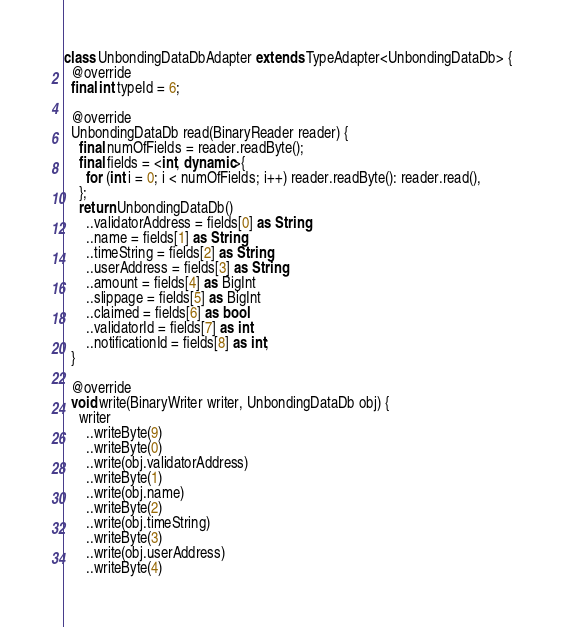Convert code to text. <code><loc_0><loc_0><loc_500><loc_500><_Dart_>class UnbondingDataDbAdapter extends TypeAdapter<UnbondingDataDb> {
  @override
  final int typeId = 6;

  @override
  UnbondingDataDb read(BinaryReader reader) {
    final numOfFields = reader.readByte();
    final fields = <int, dynamic>{
      for (int i = 0; i < numOfFields; i++) reader.readByte(): reader.read(),
    };
    return UnbondingDataDb()
      ..validatorAddress = fields[0] as String
      ..name = fields[1] as String
      ..timeString = fields[2] as String
      ..userAddress = fields[3] as String
      ..amount = fields[4] as BigInt
      ..slippage = fields[5] as BigInt
      ..claimed = fields[6] as bool
      ..validatorId = fields[7] as int
      ..notificationId = fields[8] as int;
  }

  @override
  void write(BinaryWriter writer, UnbondingDataDb obj) {
    writer
      ..writeByte(9)
      ..writeByte(0)
      ..write(obj.validatorAddress)
      ..writeByte(1)
      ..write(obj.name)
      ..writeByte(2)
      ..write(obj.timeString)
      ..writeByte(3)
      ..write(obj.userAddress)
      ..writeByte(4)</code> 